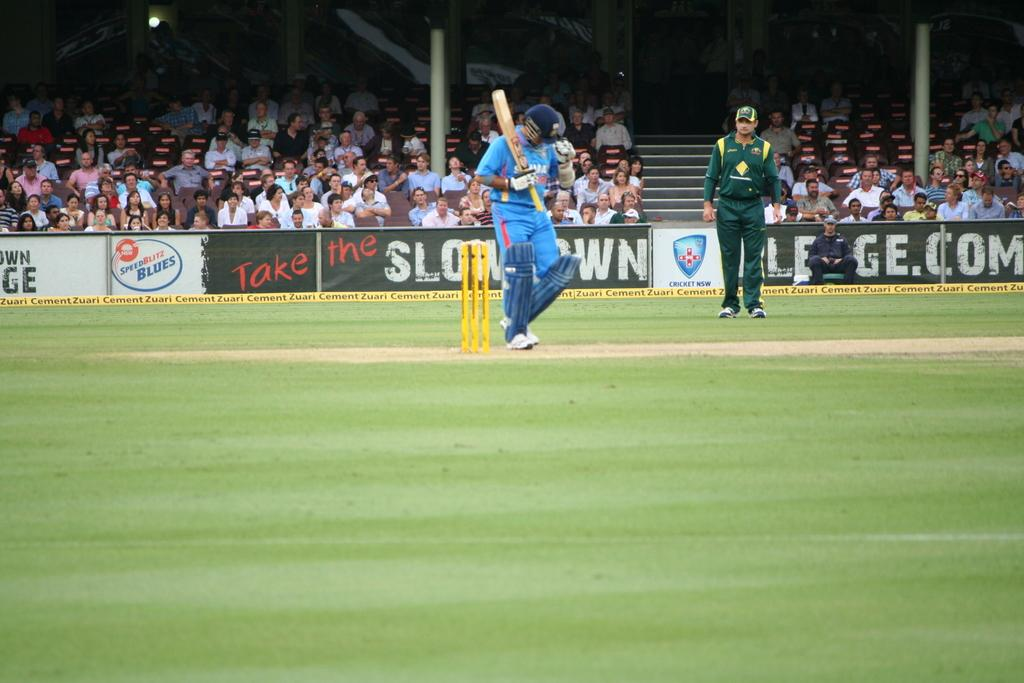<image>
Relay a brief, clear account of the picture shown. An ad for the Speed Blitz Blues is on the wall to the left of the cricket player. 